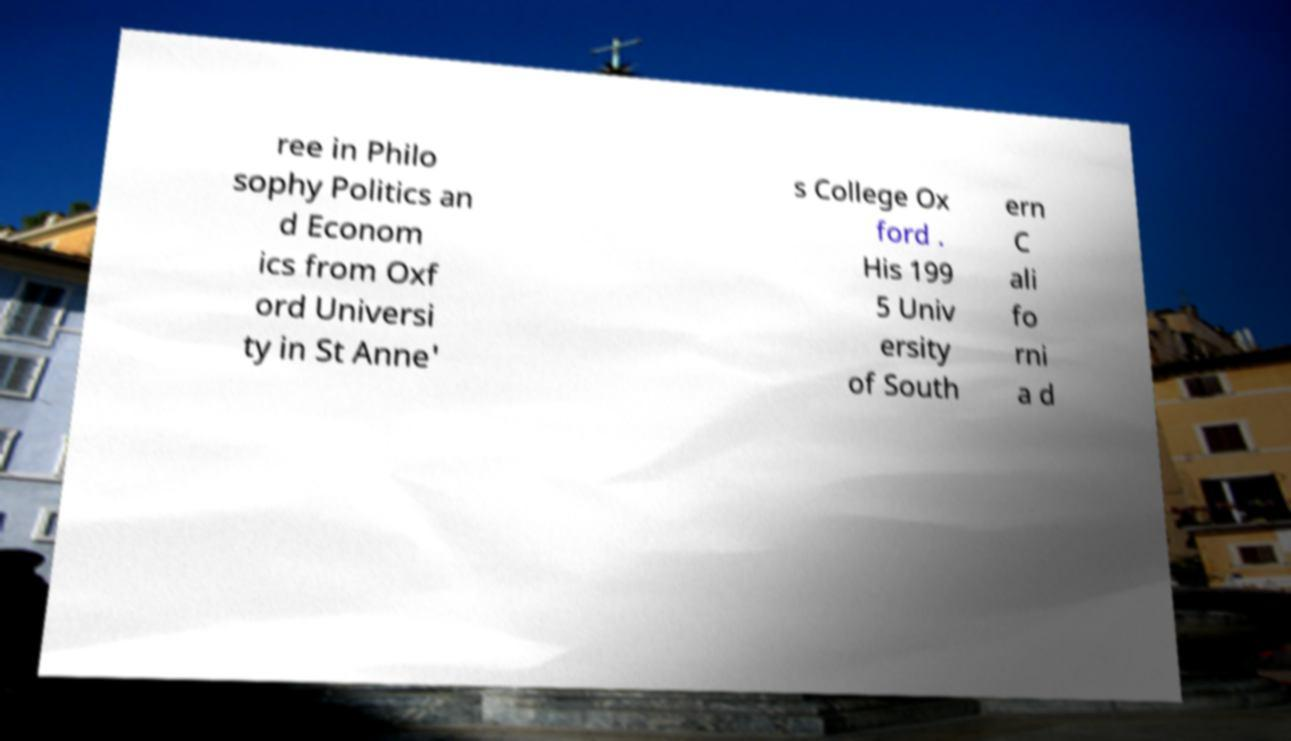Can you accurately transcribe the text from the provided image for me? ree in Philo sophy Politics an d Econom ics from Oxf ord Universi ty in St Anne' s College Ox ford . His 199 5 Univ ersity of South ern C ali fo rni a d 